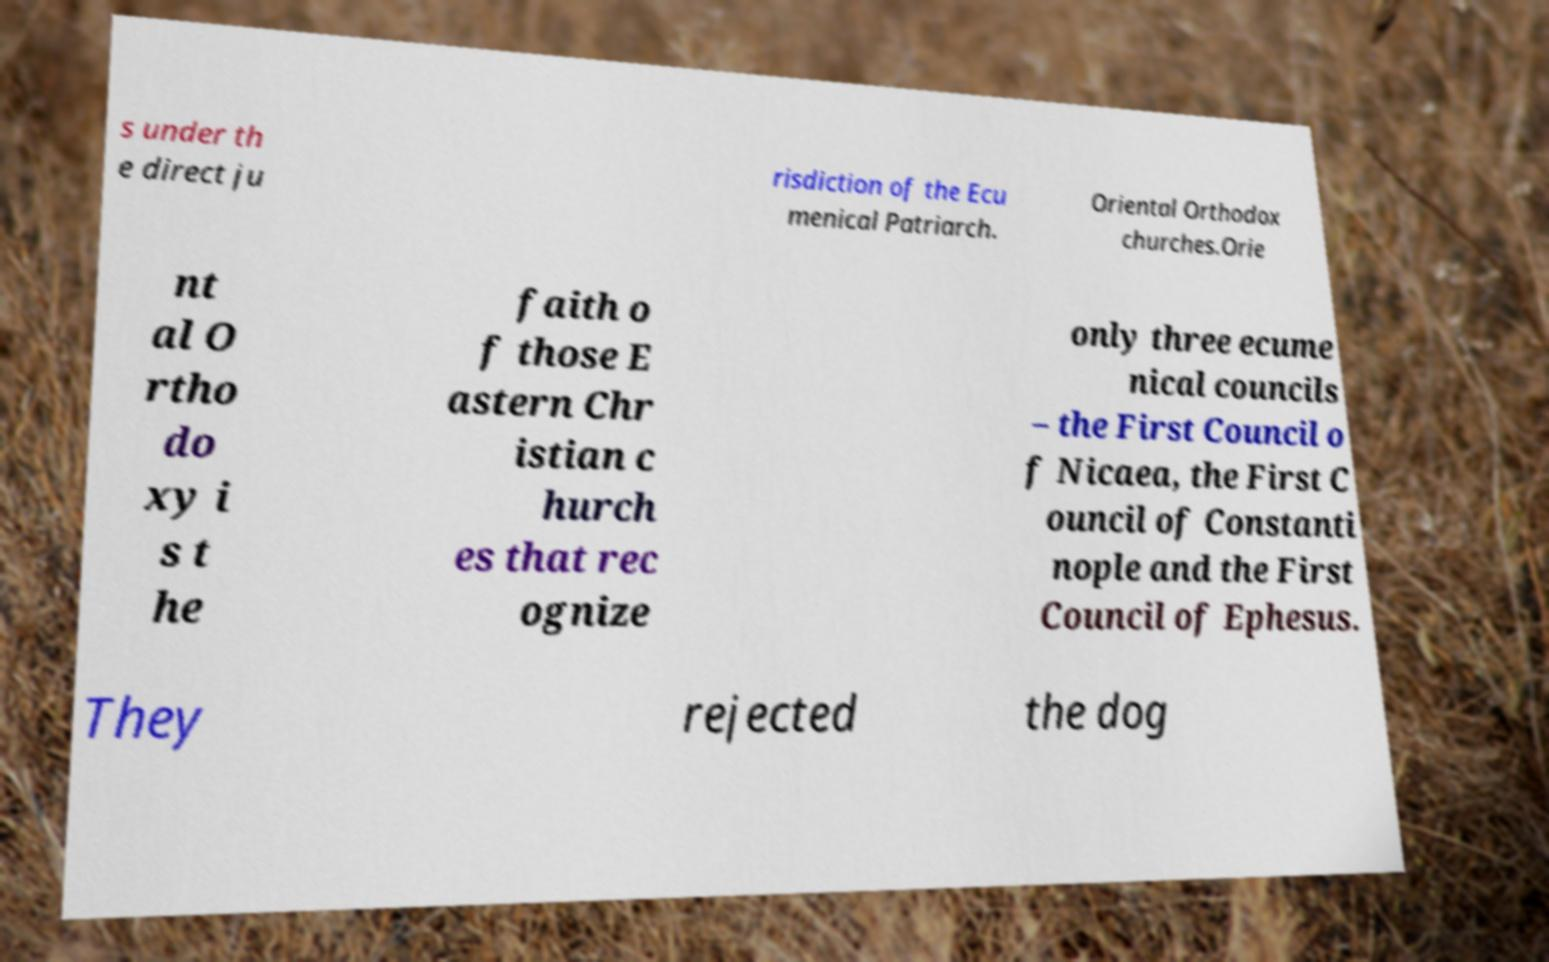I need the written content from this picture converted into text. Can you do that? s under th e direct ju risdiction of the Ecu menical Patriarch. Oriental Orthodox churches.Orie nt al O rtho do xy i s t he faith o f those E astern Chr istian c hurch es that rec ognize only three ecume nical councils – the First Council o f Nicaea, the First C ouncil of Constanti nople and the First Council of Ephesus. They rejected the dog 